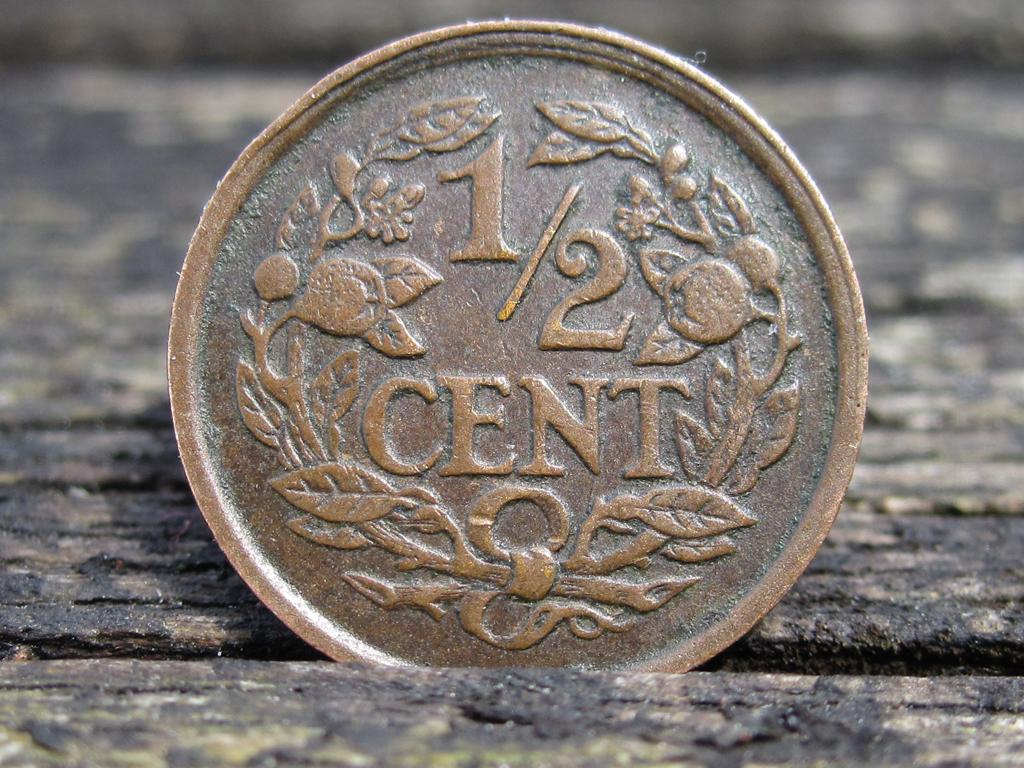<image>
Render a clear and concise summary of the photo. A copper coin that as an inscription saying one half cent. 